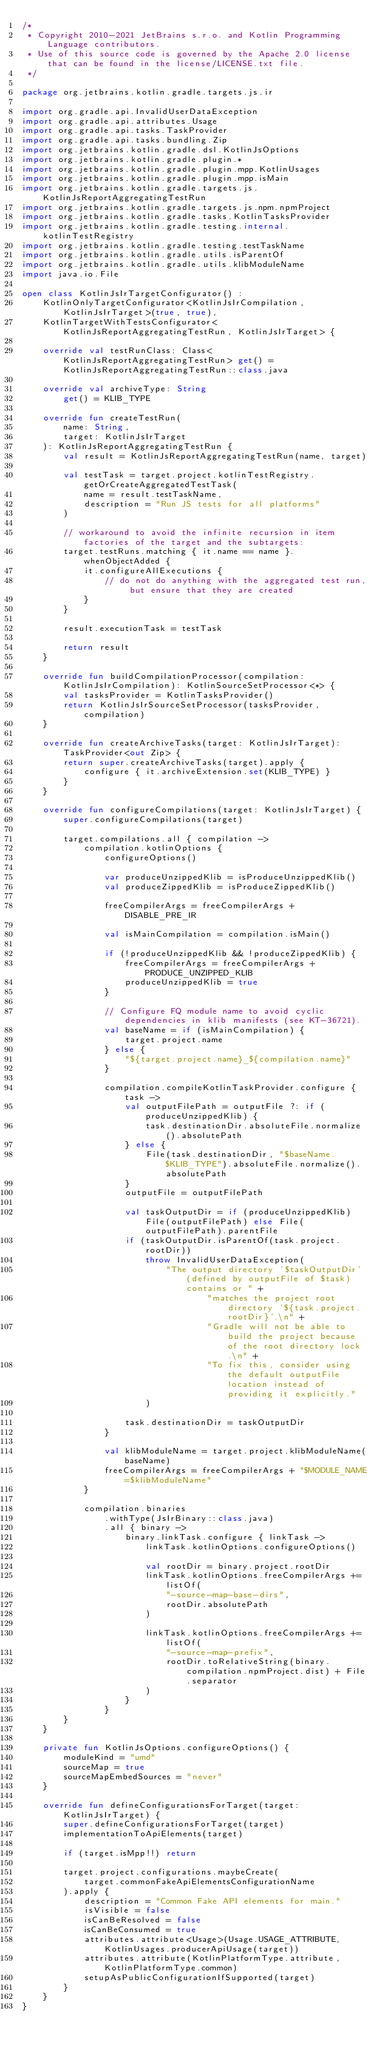<code> <loc_0><loc_0><loc_500><loc_500><_Kotlin_>/*
 * Copyright 2010-2021 JetBrains s.r.o. and Kotlin Programming Language contributors.
 * Use of this source code is governed by the Apache 2.0 license that can be found in the license/LICENSE.txt file.
 */

package org.jetbrains.kotlin.gradle.targets.js.ir

import org.gradle.api.InvalidUserDataException
import org.gradle.api.attributes.Usage
import org.gradle.api.tasks.TaskProvider
import org.gradle.api.tasks.bundling.Zip
import org.jetbrains.kotlin.gradle.dsl.KotlinJsOptions
import org.jetbrains.kotlin.gradle.plugin.*
import org.jetbrains.kotlin.gradle.plugin.mpp.KotlinUsages
import org.jetbrains.kotlin.gradle.plugin.mpp.isMain
import org.jetbrains.kotlin.gradle.targets.js.KotlinJsReportAggregatingTestRun
import org.jetbrains.kotlin.gradle.targets.js.npm.npmProject
import org.jetbrains.kotlin.gradle.tasks.KotlinTasksProvider
import org.jetbrains.kotlin.gradle.testing.internal.kotlinTestRegistry
import org.jetbrains.kotlin.gradle.testing.testTaskName
import org.jetbrains.kotlin.gradle.utils.isParentOf
import org.jetbrains.kotlin.gradle.utils.klibModuleName
import java.io.File

open class KotlinJsIrTargetConfigurator() :
    KotlinOnlyTargetConfigurator<KotlinJsIrCompilation, KotlinJsIrTarget>(true, true),
    KotlinTargetWithTestsConfigurator<KotlinJsReportAggregatingTestRun, KotlinJsIrTarget> {

    override val testRunClass: Class<KotlinJsReportAggregatingTestRun> get() = KotlinJsReportAggregatingTestRun::class.java

    override val archiveType: String
        get() = KLIB_TYPE

    override fun createTestRun(
        name: String,
        target: KotlinJsIrTarget
    ): KotlinJsReportAggregatingTestRun {
        val result = KotlinJsReportAggregatingTestRun(name, target)

        val testTask = target.project.kotlinTestRegistry.getOrCreateAggregatedTestTask(
            name = result.testTaskName,
            description = "Run JS tests for all platforms"
        )

        // workaround to avoid the infinite recursion in item factories of the target and the subtargets:
        target.testRuns.matching { it.name == name }.whenObjectAdded {
            it.configureAllExecutions {
                // do not do anything with the aggregated test run, but ensure that they are created
            }
        }

        result.executionTask = testTask

        return result
    }

    override fun buildCompilationProcessor(compilation: KotlinJsIrCompilation): KotlinSourceSetProcessor<*> {
        val tasksProvider = KotlinTasksProvider()
        return KotlinJsIrSourceSetProcessor(tasksProvider, compilation)
    }

    override fun createArchiveTasks(target: KotlinJsIrTarget): TaskProvider<out Zip> {
        return super.createArchiveTasks(target).apply {
            configure { it.archiveExtension.set(KLIB_TYPE) }
        }
    }

    override fun configureCompilations(target: KotlinJsIrTarget) {
        super.configureCompilations(target)

        target.compilations.all { compilation ->
            compilation.kotlinOptions {
                configureOptions()

                var produceUnzippedKlib = isProduceUnzippedKlib()
                val produceZippedKlib = isProduceZippedKlib()

                freeCompilerArgs = freeCompilerArgs + DISABLE_PRE_IR

                val isMainCompilation = compilation.isMain()

                if (!produceUnzippedKlib && !produceZippedKlib) {
                    freeCompilerArgs = freeCompilerArgs + PRODUCE_UNZIPPED_KLIB
                    produceUnzippedKlib = true
                }

                // Configure FQ module name to avoid cyclic dependencies in klib manifests (see KT-36721).
                val baseName = if (isMainCompilation) {
                    target.project.name
                } else {
                    "${target.project.name}_${compilation.name}"
                }

                compilation.compileKotlinTaskProvider.configure { task ->
                    val outputFilePath = outputFile ?: if (produceUnzippedKlib) {
                        task.destinationDir.absoluteFile.normalize().absolutePath
                    } else {
                        File(task.destinationDir, "$baseName.$KLIB_TYPE").absoluteFile.normalize().absolutePath
                    }
                    outputFile = outputFilePath

                    val taskOutputDir = if (produceUnzippedKlib) File(outputFilePath) else File(outputFilePath).parentFile
                    if (taskOutputDir.isParentOf(task.project.rootDir))
                        throw InvalidUserDataException(
                            "The output directory '$taskOutputDir' (defined by outputFile of $task) contains or " +
                                    "matches the project root directory '${task.project.rootDir}'.\n" +
                                    "Gradle will not be able to build the project because of the root directory lock.\n" +
                                    "To fix this, consider using the default outputFile location instead of providing it explicitly."
                        )

                    task.destinationDir = taskOutputDir
                }

                val klibModuleName = target.project.klibModuleName(baseName)
                freeCompilerArgs = freeCompilerArgs + "$MODULE_NAME=$klibModuleName"
            }

            compilation.binaries
                .withType(JsIrBinary::class.java)
                .all { binary ->
                    binary.linkTask.configure { linkTask ->
                        linkTask.kotlinOptions.configureOptions()

                        val rootDir = binary.project.rootDir
                        linkTask.kotlinOptions.freeCompilerArgs += listOf(
                            "-source-map-base-dirs",
                            rootDir.absolutePath
                        )

                        linkTask.kotlinOptions.freeCompilerArgs += listOf(
                            "-source-map-prefix",
                            rootDir.toRelativeString(binary.compilation.npmProject.dist) + File.separator
                        )
                    }
                }
        }
    }

    private fun KotlinJsOptions.configureOptions() {
        moduleKind = "umd"
        sourceMap = true
        sourceMapEmbedSources = "never"
    }

    override fun defineConfigurationsForTarget(target: KotlinJsIrTarget) {
        super.defineConfigurationsForTarget(target)
        implementationToApiElements(target)

        if (target.isMpp!!) return

        target.project.configurations.maybeCreate(
            target.commonFakeApiElementsConfigurationName
        ).apply {
            description = "Common Fake API elements for main."
            isVisible = false
            isCanBeResolved = false
            isCanBeConsumed = true
            attributes.attribute<Usage>(Usage.USAGE_ATTRIBUTE, KotlinUsages.producerApiUsage(target))
            attributes.attribute(KotlinPlatformType.attribute, KotlinPlatformType.common)
            setupAsPublicConfigurationIfSupported(target)
        }
    }
}
</code> 